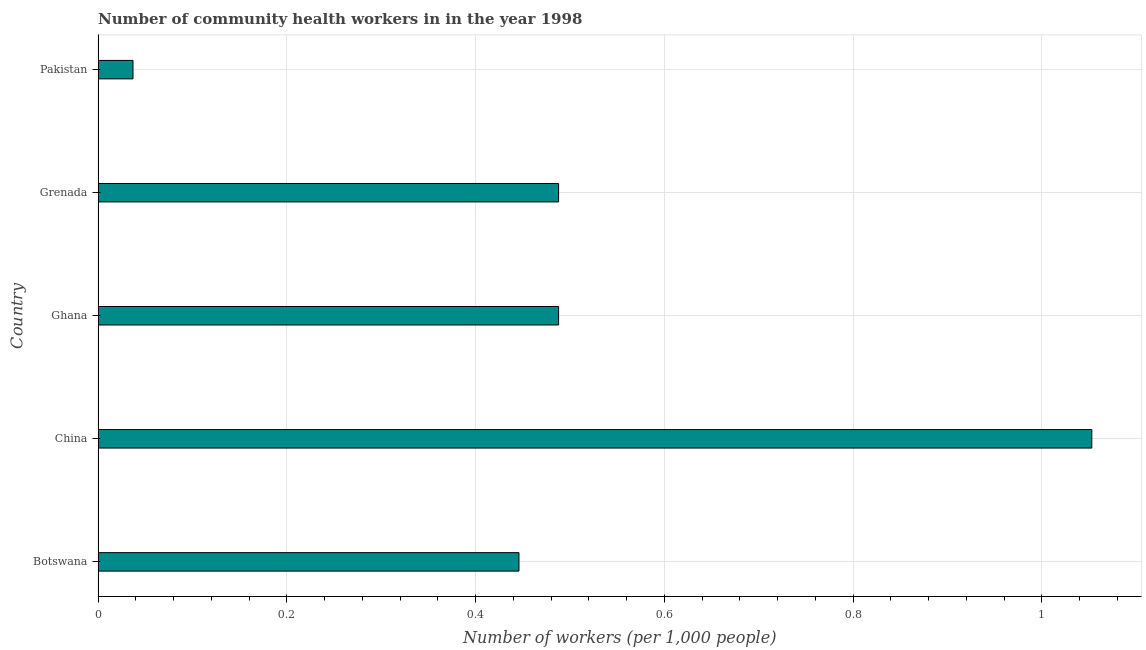Does the graph contain any zero values?
Give a very brief answer. No. What is the title of the graph?
Give a very brief answer. Number of community health workers in in the year 1998. What is the label or title of the X-axis?
Your answer should be very brief. Number of workers (per 1,0 people). What is the number of community health workers in China?
Your answer should be compact. 1.05. Across all countries, what is the maximum number of community health workers?
Give a very brief answer. 1.05. Across all countries, what is the minimum number of community health workers?
Your answer should be very brief. 0.04. What is the sum of the number of community health workers?
Your answer should be very brief. 2.51. What is the average number of community health workers per country?
Offer a terse response. 0.5. What is the median number of community health workers?
Provide a succinct answer. 0.49. What is the ratio of the number of community health workers in Botswana to that in China?
Give a very brief answer. 0.42. What is the difference between the highest and the second highest number of community health workers?
Provide a short and direct response. 0.56. Is the sum of the number of community health workers in Botswana and Pakistan greater than the maximum number of community health workers across all countries?
Offer a terse response. No. What is the difference between the highest and the lowest number of community health workers?
Your answer should be very brief. 1.02. How many bars are there?
Your answer should be compact. 5. Are all the bars in the graph horizontal?
Your answer should be very brief. Yes. What is the difference between two consecutive major ticks on the X-axis?
Ensure brevity in your answer.  0.2. What is the Number of workers (per 1,000 people) of Botswana?
Your response must be concise. 0.45. What is the Number of workers (per 1,000 people) of China?
Your answer should be very brief. 1.05. What is the Number of workers (per 1,000 people) of Ghana?
Your answer should be compact. 0.49. What is the Number of workers (per 1,000 people) in Grenada?
Your response must be concise. 0.49. What is the Number of workers (per 1,000 people) in Pakistan?
Offer a terse response. 0.04. What is the difference between the Number of workers (per 1,000 people) in Botswana and China?
Make the answer very short. -0.61. What is the difference between the Number of workers (per 1,000 people) in Botswana and Ghana?
Make the answer very short. -0.04. What is the difference between the Number of workers (per 1,000 people) in Botswana and Grenada?
Offer a terse response. -0.04. What is the difference between the Number of workers (per 1,000 people) in Botswana and Pakistan?
Your answer should be compact. 0.41. What is the difference between the Number of workers (per 1,000 people) in China and Ghana?
Offer a terse response. 0.56. What is the difference between the Number of workers (per 1,000 people) in China and Grenada?
Your answer should be compact. 0.56. What is the difference between the Number of workers (per 1,000 people) in China and Pakistan?
Your answer should be very brief. 1.02. What is the difference between the Number of workers (per 1,000 people) in Ghana and Grenada?
Offer a terse response. 0. What is the difference between the Number of workers (per 1,000 people) in Ghana and Pakistan?
Give a very brief answer. 0.45. What is the difference between the Number of workers (per 1,000 people) in Grenada and Pakistan?
Ensure brevity in your answer.  0.45. What is the ratio of the Number of workers (per 1,000 people) in Botswana to that in China?
Your answer should be compact. 0.42. What is the ratio of the Number of workers (per 1,000 people) in Botswana to that in Ghana?
Your answer should be very brief. 0.91. What is the ratio of the Number of workers (per 1,000 people) in Botswana to that in Grenada?
Make the answer very short. 0.91. What is the ratio of the Number of workers (per 1,000 people) in Botswana to that in Pakistan?
Keep it short and to the point. 12.05. What is the ratio of the Number of workers (per 1,000 people) in China to that in Ghana?
Your answer should be very brief. 2.16. What is the ratio of the Number of workers (per 1,000 people) in China to that in Grenada?
Your answer should be very brief. 2.16. What is the ratio of the Number of workers (per 1,000 people) in China to that in Pakistan?
Provide a short and direct response. 28.46. What is the ratio of the Number of workers (per 1,000 people) in Ghana to that in Pakistan?
Your answer should be very brief. 13.19. What is the ratio of the Number of workers (per 1,000 people) in Grenada to that in Pakistan?
Your response must be concise. 13.19. 